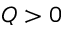<formula> <loc_0><loc_0><loc_500><loc_500>Q > 0</formula> 